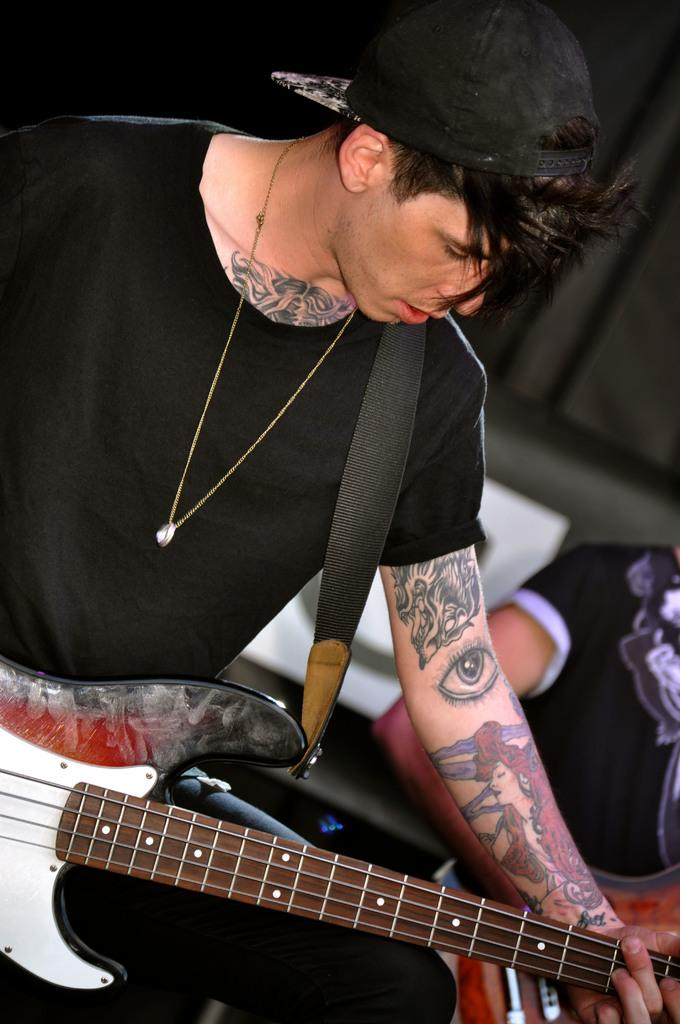What is the main subject of the image? There is a person in the image. What is the person wearing? The person is wearing a black shirt. What activity is the person engaged in? The person is playing a guitar. Can you describe any distinctive features of the person's appearance? The person has many tattoos on their body. What type of skin is visible on the person's head in the image? There is no information about the person's skin or hair in the image, as the focus is on their clothing and activity. 